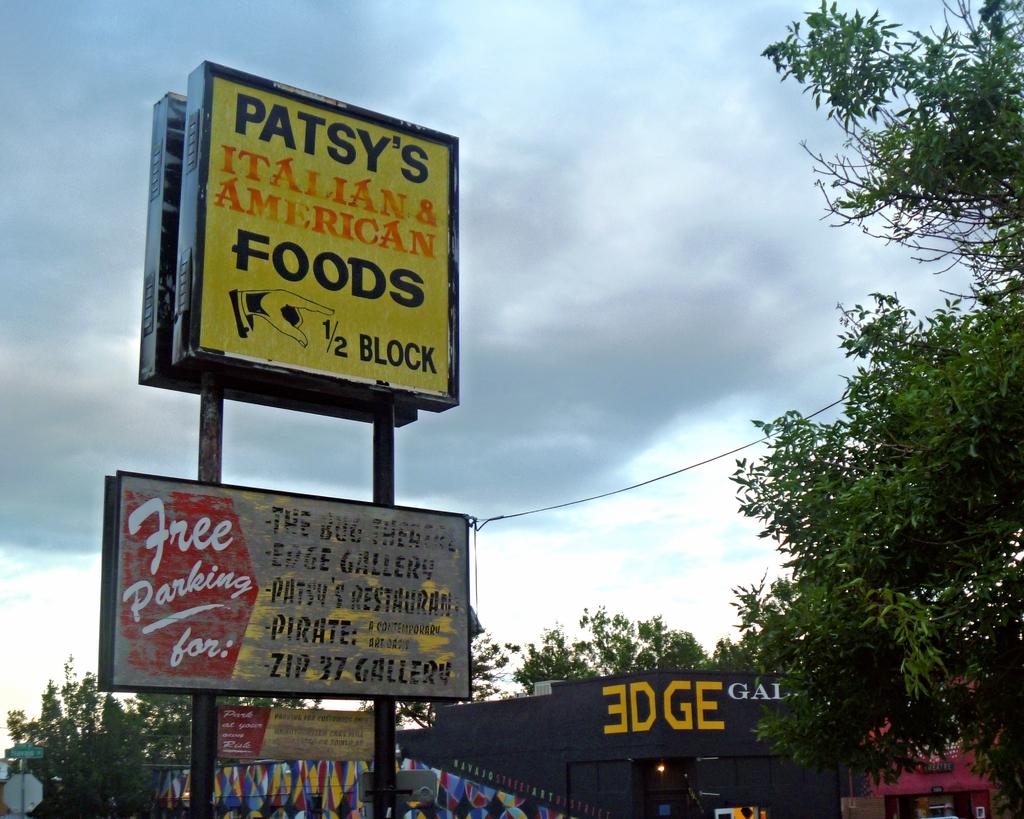What kind of food does patsy's food have?
Offer a very short reply. Italian and american foods. How far is patsy?
Your response must be concise. 1/2 block. 